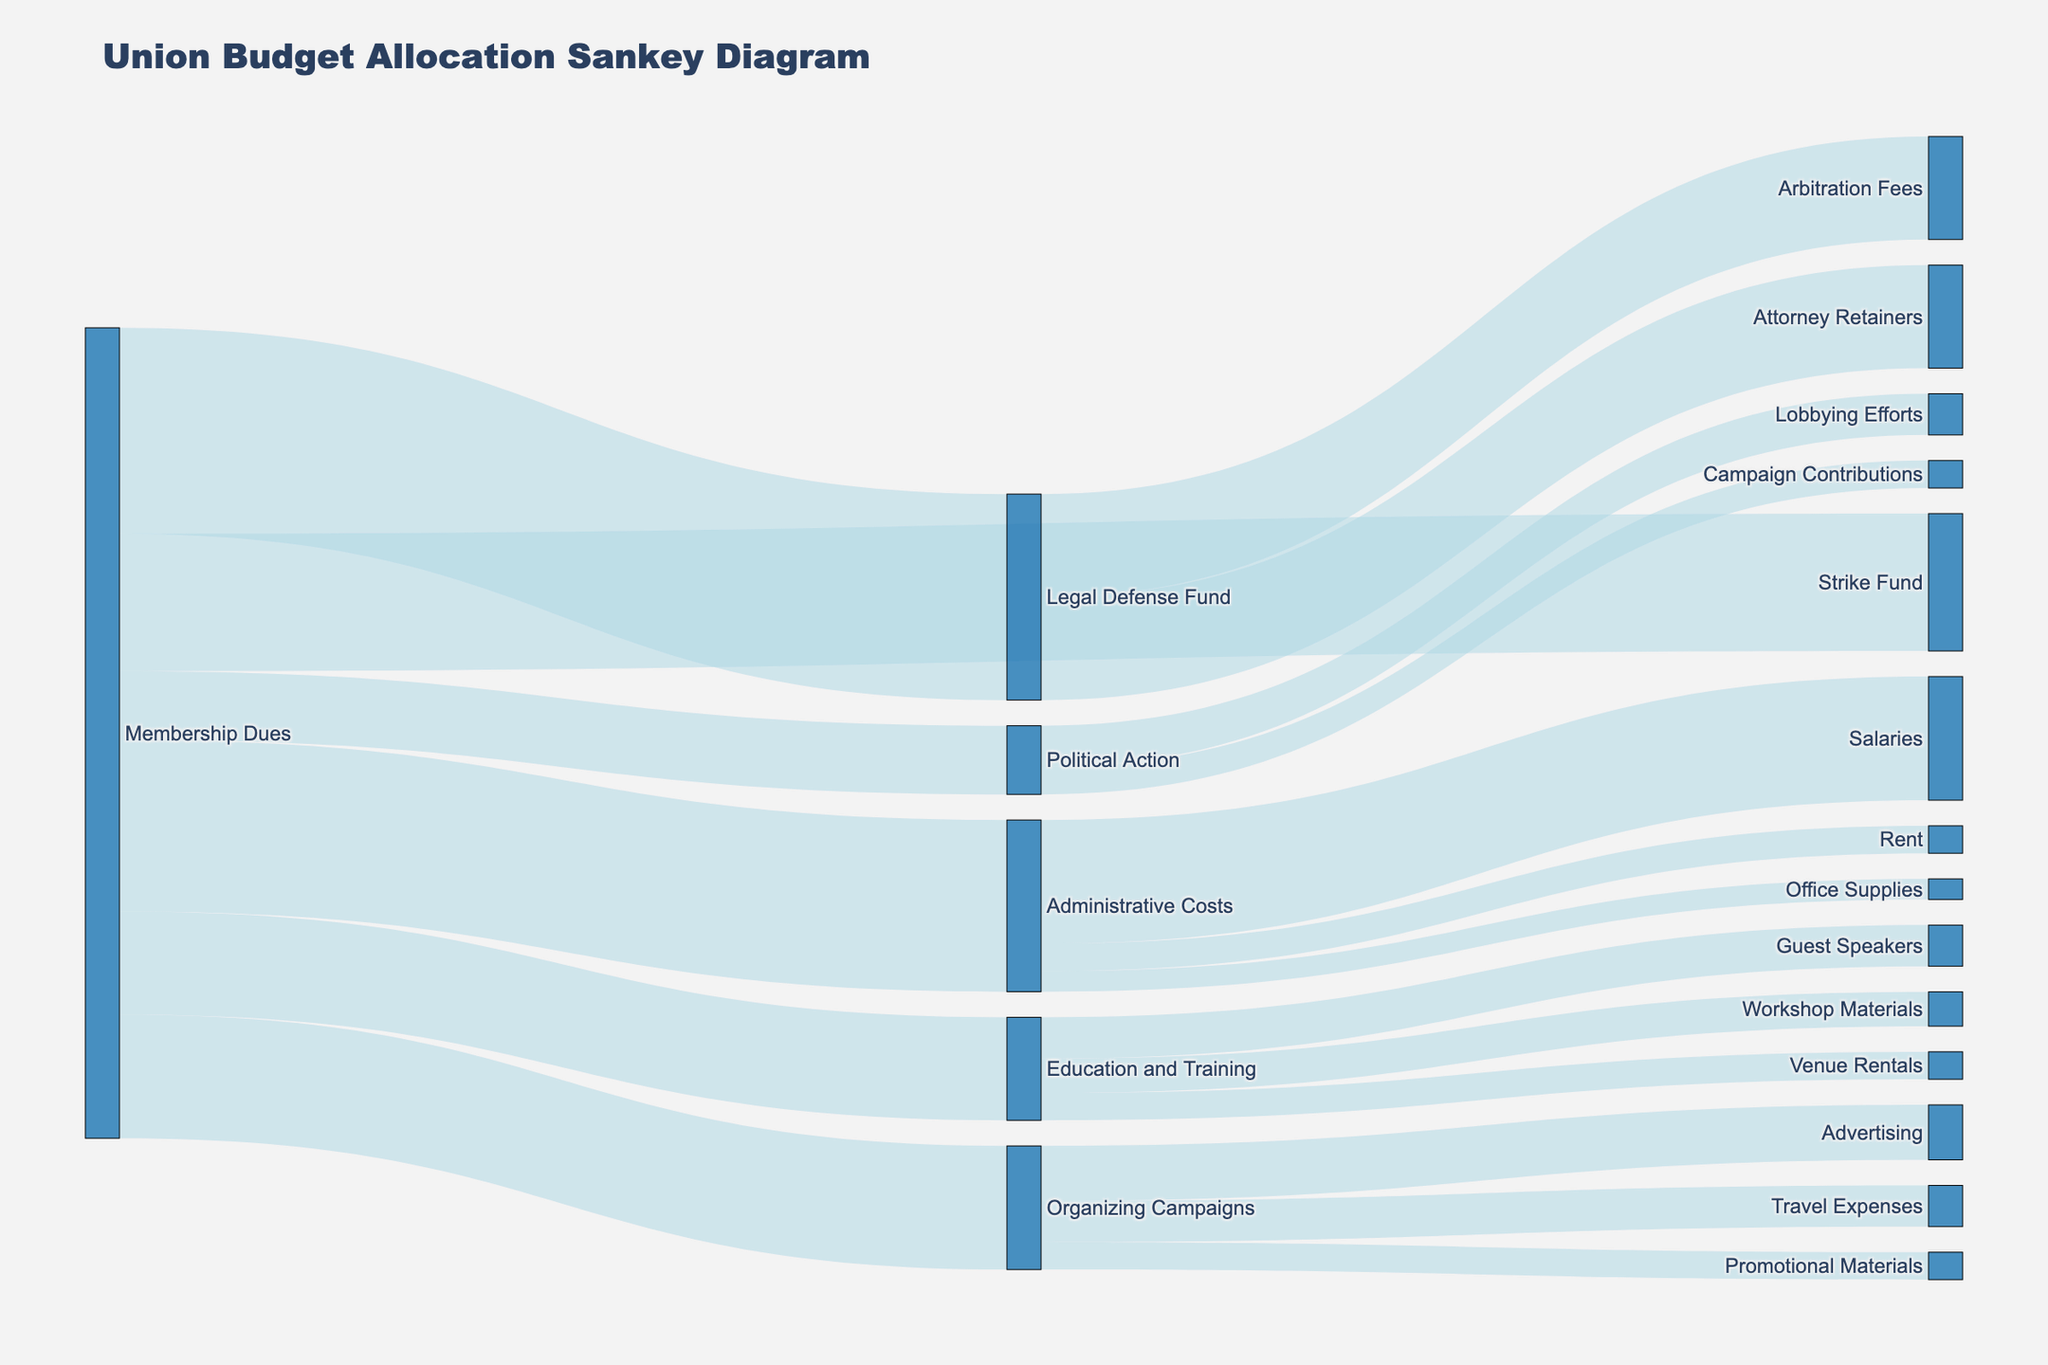What is the total budget allocated from Membership Dues? The sum of all values flowing from Membership Dues can be calculated: 250000 (Administrative Costs) + 300000 (Legal Defense Fund) + 200000 (Strike Fund) + 150000 (Education and Training) + 180000 (Organizing Campaigns) + 100000 (Political Action) = 1180000
Answer: 1180000 What is the highest single expenditure from Membership Dues and to which target does it go? The largest value directly connected from Membership Dues, which is 300000, goes to the Legal Defense Fund.
Answer: Legal Defense Fund Which category receives funding for Office Supplies, and how much is allocated for it? The Office Supplies is listed under Administrative Costs, with an allocation of 30000.
Answer: Administrative Costs, 30000 What is the difference between the amounts allocated to the Strike Fund and the Political Action? The Strike Fund receives 200000, and Political Action receives 100000. The difference is 200000 - 100000 = 100000.
Answer: 100000 How is the budget for Education and Training distributed among its subcategories? Education and Training includes Workshop Materials (50000), Guest Speakers (60000), and Venue Rentals (40000). Adding these amounts gives 50000 + 60000 + 40000 = 150000.
Answer: 50000 Workshop Materials, 60000 Guest Speakers, 40000 Venue Rentals Which receives more funding: Organizing Campaigns or Administrative Costs? Administrative Costs receive 250000, and Organizing Campaigns receive 180000. Therefore, Administrative Costs receive more funding.
Answer: Administrative Costs What is the amount allocated for salary expenses within the Administrative Costs category? Within the Administrative Costs, the amount designated for Salaries is 180000.
Answer: 180000 How much funding is allocated across all categories under the Legal Defense Fund? Legal Defense Fund has two allocations: Arbitration Fees (150000) and Attorney Retainers (150000). Total is 150000 + 150000 = 300000.
Answer: 300000 